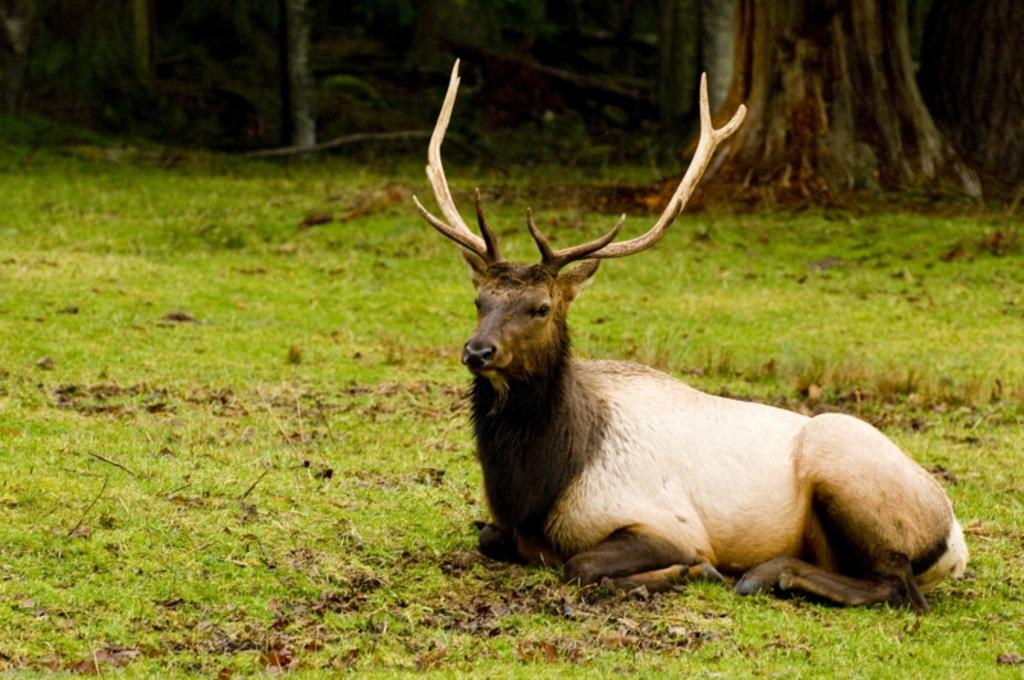What animal can be seen in the image? There is a deer in the image. Where is the deer located? The deer is on the ground. What can be seen in the background of the image? There is a group of trees in the background of the image. What type of needle is the deer using to sew a blanket in the image? There is no needle or blanket present in the image; it features a deer on the ground with trees in the background. 